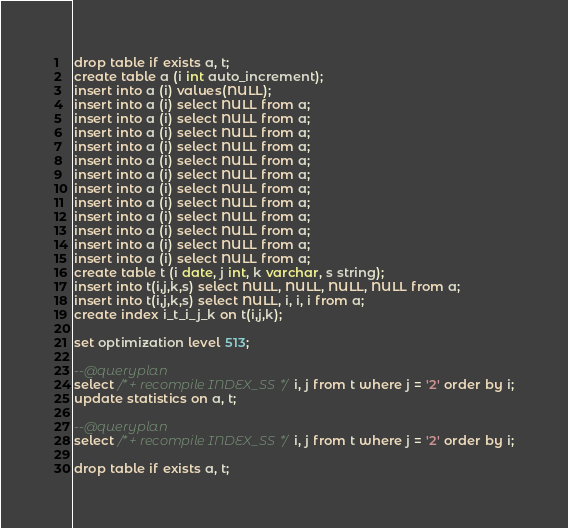<code> <loc_0><loc_0><loc_500><loc_500><_SQL_>drop table if exists a, t;
create table a (i int auto_increment);
insert into a (i) values(NULL);
insert into a (i) select NULL from a;
insert into a (i) select NULL from a;
insert into a (i) select NULL from a;
insert into a (i) select NULL from a;
insert into a (i) select NULL from a;
insert into a (i) select NULL from a;
insert into a (i) select NULL from a;
insert into a (i) select NULL from a;
insert into a (i) select NULL from a;
insert into a (i) select NULL from a;
insert into a (i) select NULL from a;
insert into a (i) select NULL from a;
create table t (i date, j int, k varchar, s string);
insert into t(i,j,k,s) select NULL, NULL, NULL, NULL from a;
insert into t(i,j,k,s) select NULL, i, i, i from a;
create index i_t_i_j_k on t(i,j,k);

set optimization level 513;

--@queryplan
select /*+ recompile INDEX_SS*/ i, j from t where j = '2' order by i;
update statistics on a, t;

--@queryplan
select /*+ recompile INDEX_SS*/ i, j from t where j = '2' order by i;

drop table if exists a, t;
</code> 